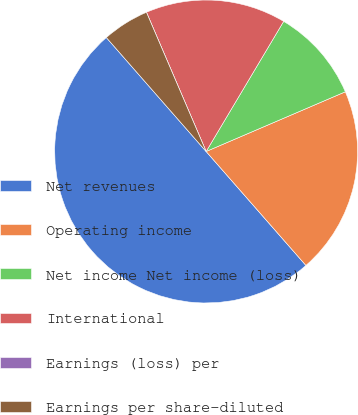Convert chart to OTSL. <chart><loc_0><loc_0><loc_500><loc_500><pie_chart><fcel>Net revenues<fcel>Operating income<fcel>Net income Net income (loss)<fcel>International<fcel>Earnings (loss) per<fcel>Earnings per share-diluted<nl><fcel>50.0%<fcel>20.0%<fcel>10.0%<fcel>15.0%<fcel>0.0%<fcel>5.0%<nl></chart> 